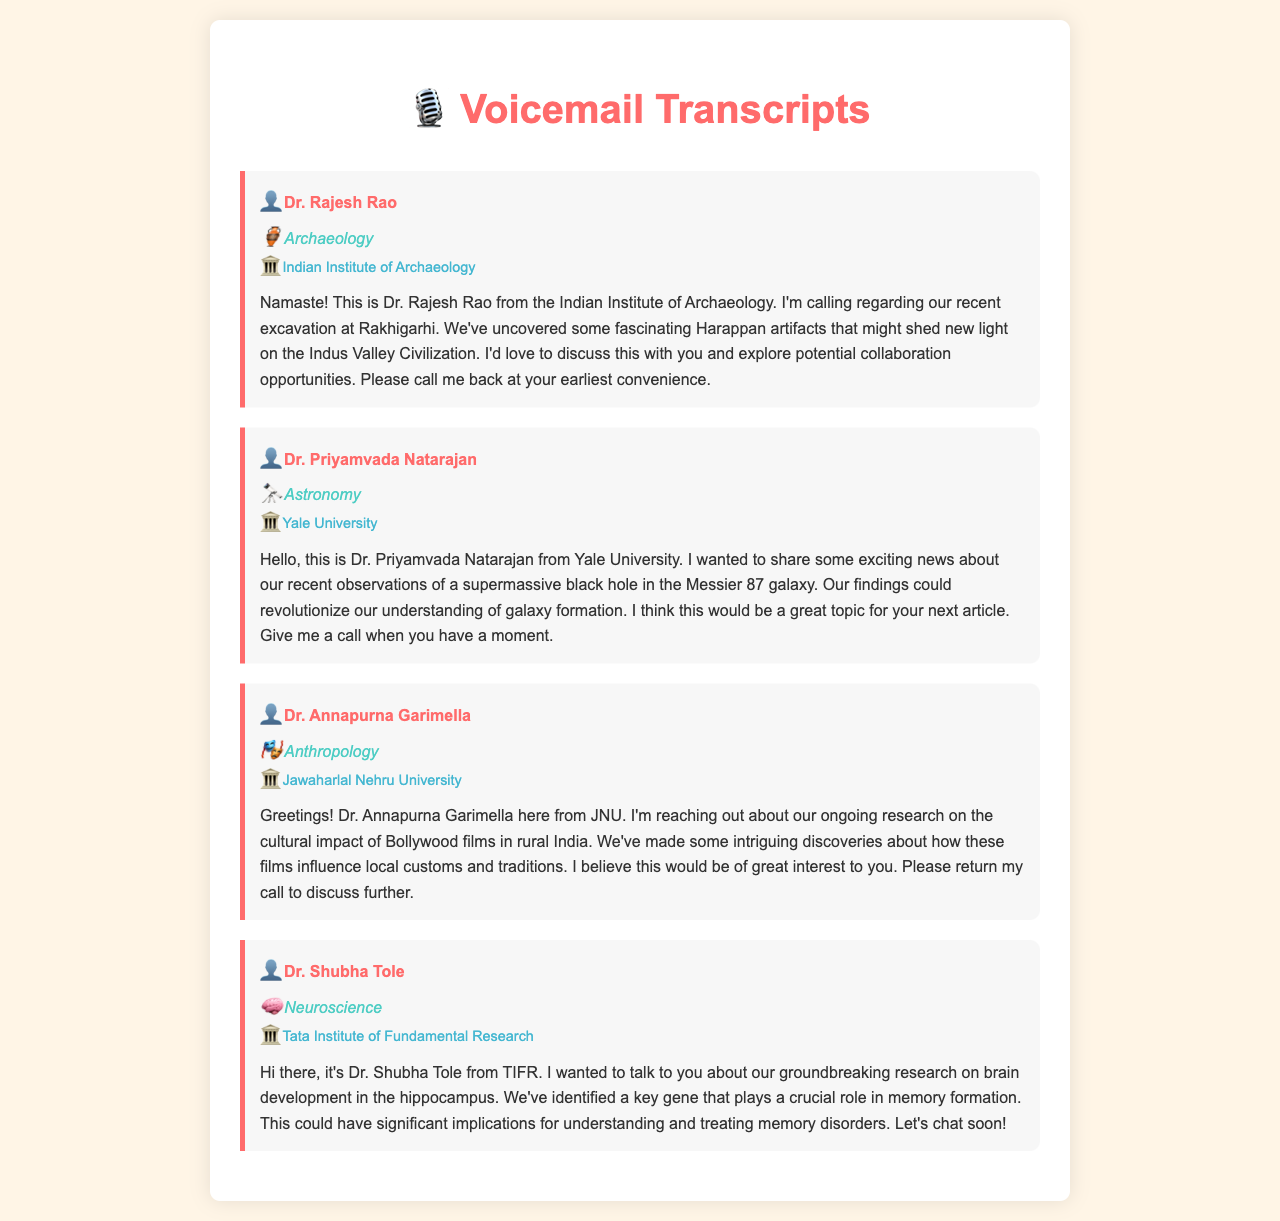What is the name of the archaeologist mentioned? The voicemail mentions Dr. Rajesh Rao as the archaeologist.
Answer: Dr. Rajesh Rao Which institution does Dr. Priyamvada Natarajan represent? Dr. Priyamvada Natarajan is from Yale University.
Answer: Yale University What recent observation is discussed by Dr. Priyamvada Natarajan? Dr. Priyamvada Natarajan talks about a supermassive black hole in the Messier 87 galaxy.
Answer: supermassive black hole in the Messier 87 galaxy What cultural topic is Dr. Annapurna Garimella researching? Dr. Annapurna Garimella is researching the cultural impact of Bollywood films.
Answer: Bollywood films Which field does Dr. Shubha Tole specialize in? The document states that Dr. Shubha Tole specializes in Neuroscience.
Answer: Neuroscience How many researchers are mentioned in the document? There are four researchers mentioned in the document.
Answer: four What is the focus of Dr. Shubha Tole's research? Dr. Shubha Tole's research focuses on brain development in the hippocampus.
Answer: brain development in the hippocampus What is the main theme of Dr. Annapurna Garimella's message? The main theme of Dr. Garimella's message is about Bollywood's influence on local customs.
Answer: Bollywood's influence on local customs At which institution is the Indian Institute of Archaeology located? The Indian Institute of Archaeology is not explicitly stated but is implied to be in India.
Answer: India 